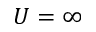Convert formula to latex. <formula><loc_0><loc_0><loc_500><loc_500>U = \infty</formula> 